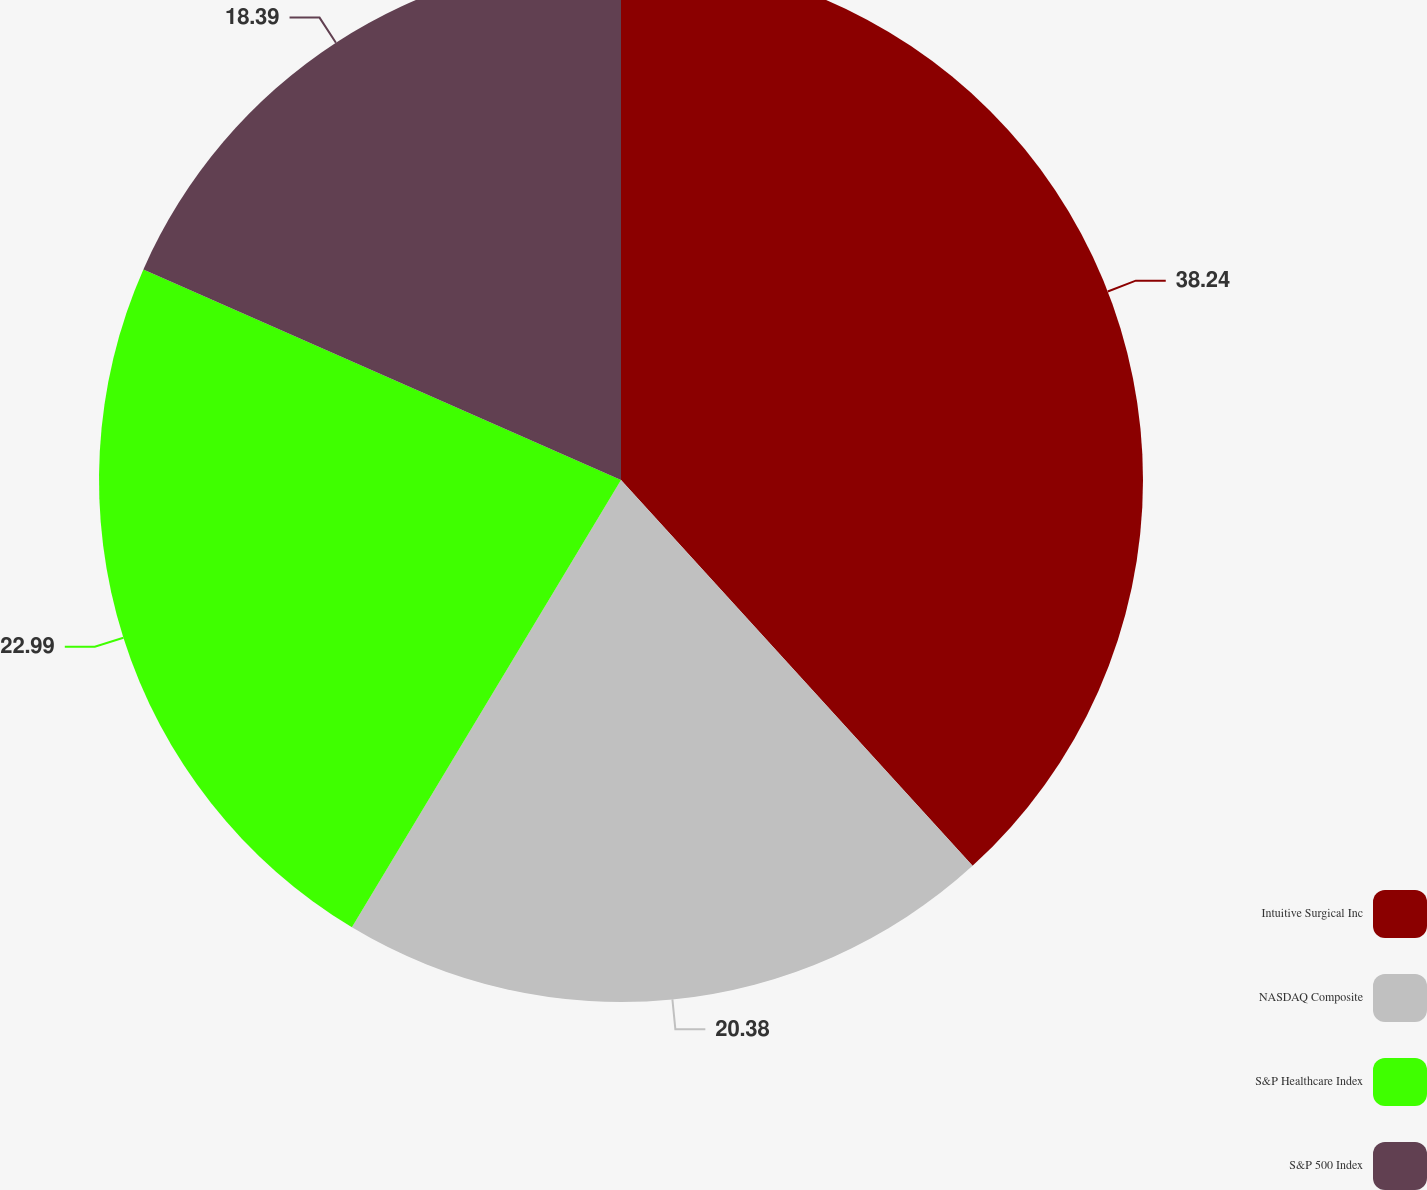Convert chart. <chart><loc_0><loc_0><loc_500><loc_500><pie_chart><fcel>Intuitive Surgical Inc<fcel>NASDAQ Composite<fcel>S&P Healthcare Index<fcel>S&P 500 Index<nl><fcel>38.24%<fcel>20.38%<fcel>22.99%<fcel>18.39%<nl></chart> 